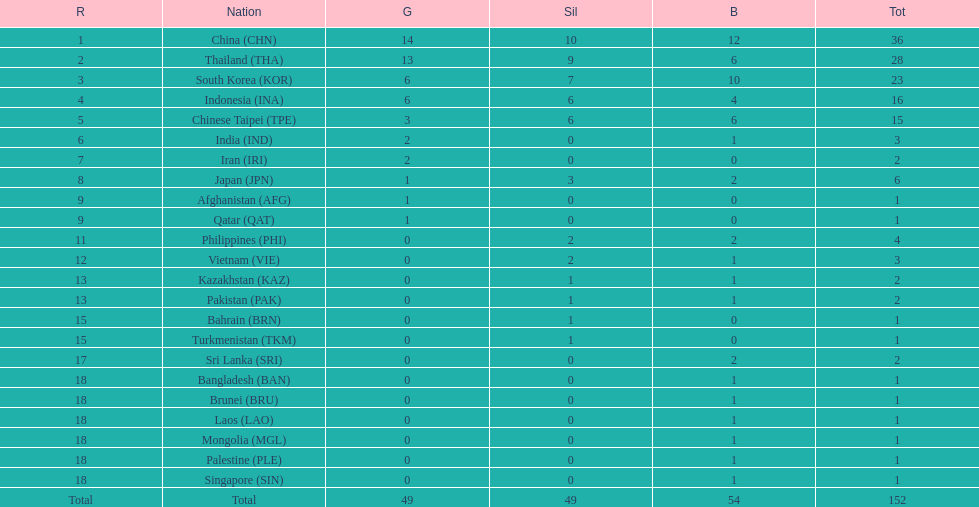How many nations received a medal in each gold, silver, and bronze? 6. 